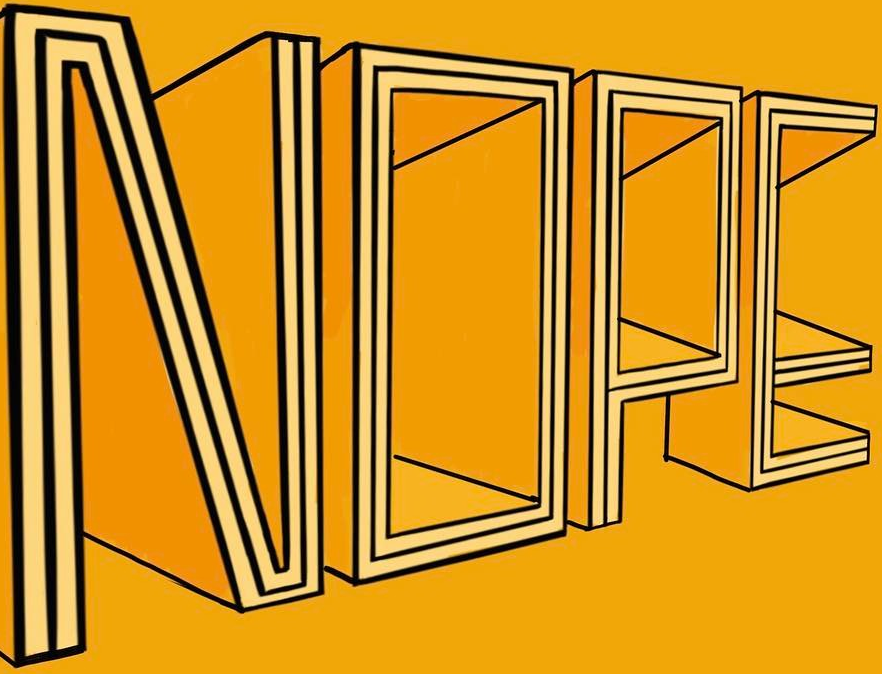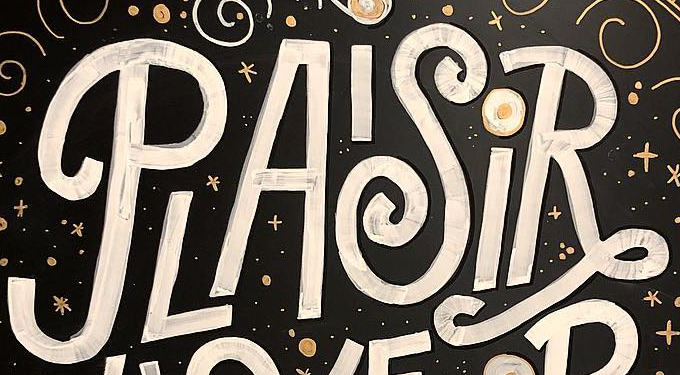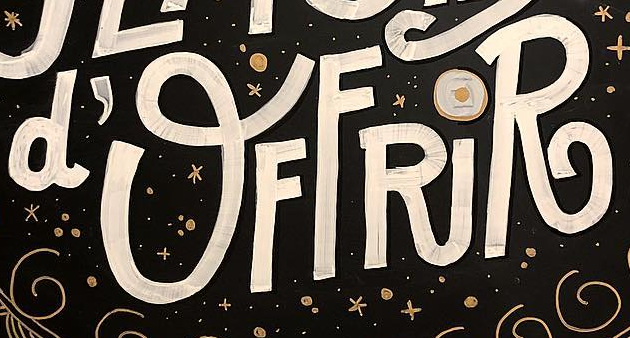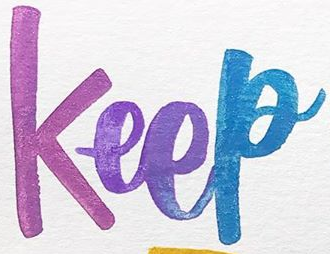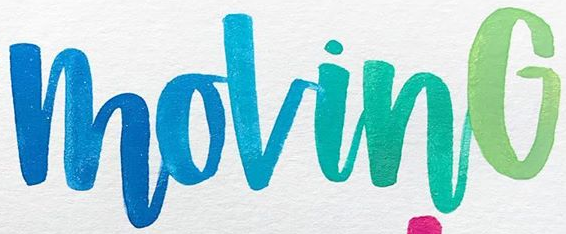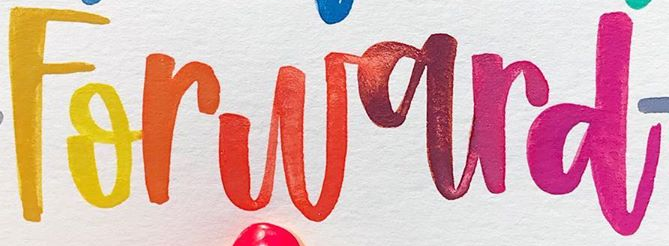Read the text from these images in sequence, separated by a semicolon. NOPE; PLAISiR; d'OFFRiR; Keep; MovinG; Forward 